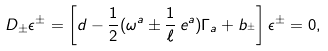<formula> <loc_0><loc_0><loc_500><loc_500>D _ { \pm } \epsilon ^ { \pm } = \left [ d - \frac { 1 } { 2 } ( \omega ^ { a } \pm \frac { 1 } { \ell } \, e ^ { a } ) \Gamma _ { a } + b _ { ^ { \pm } } \right ] \epsilon ^ { \pm } = 0 ,</formula> 